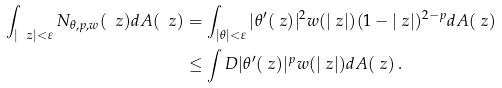Convert formula to latex. <formula><loc_0><loc_0><loc_500><loc_500>\int _ { | \ z | < \varepsilon } N _ { \theta , p , w } ( \ z ) d A ( \ z ) & = \int _ { | \theta | < \varepsilon } | \theta ^ { \prime } ( \ z ) | ^ { 2 } w ( | \ z | ) ( 1 - | \ z | ) ^ { 2 - p } d A ( \ z ) \\ & \leq \int _ { \ } D | \theta ^ { \prime } ( \ z ) | ^ { p } w ( | \ z | ) d A ( \ z ) \, .</formula> 